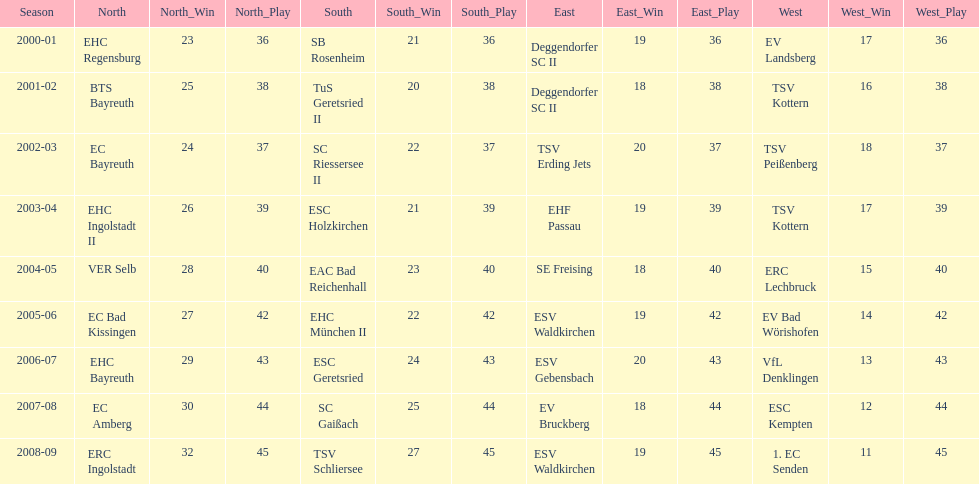Who secured the win in the south subsequent to esc geretsried's participation in the 2006-07 season? SC Gaißach. Would you mind parsing the complete table? {'header': ['Season', 'North', 'North_Win', 'North_Play', 'South', 'South_Win', 'South_Play', 'East', 'East_Win', 'East_Play', 'West', 'West_Win', 'West_Play'], 'rows': [['2000-01', 'EHC Regensburg', '23', '36', 'SB Rosenheim', '21', '36', 'Deggendorfer SC II', '19', '36', 'EV Landsberg', '17', '36'], ['2001-02', 'BTS Bayreuth', '25', '38', 'TuS Geretsried II', '20', '38', 'Deggendorfer SC II', '18', '38', 'TSV Kottern', '16', '38'], ['2002-03', 'EC Bayreuth', '24', '37', 'SC Riessersee II', '22', '37', 'TSV Erding Jets', '20', '37', 'TSV Peißenberg', '18', '37'], ['2003-04', 'EHC Ingolstadt II', '26', '39', 'ESC Holzkirchen', '21', '39', 'EHF Passau', '19', '39', 'TSV Kottern', '17', '39'], ['2004-05', 'VER Selb', '28', '40', 'EAC Bad Reichenhall', '23', '40', 'SE Freising', '18', '40', 'ERC Lechbruck', '15', '40'], ['2005-06', 'EC Bad Kissingen', '27', '42', 'EHC München II', '22', '42', 'ESV Waldkirchen', '19', '42', 'EV Bad Wörishofen', '14', '42'], ['2006-07', 'EHC Bayreuth', '29', '43', 'ESC Geretsried', '24', '43', 'ESV Gebensbach', '20', '43', 'VfL Denklingen', '13', '43'], ['2007-08', 'EC Amberg', '30', '44', 'SC Gaißach', '25', '44', 'EV Bruckberg', '18', '44', 'ESC Kempten', '12', '44'], ['2008-09', 'ERC Ingolstadt', '32', '45', 'TSV Schliersee', '27', '45', 'ESV Waldkirchen', '19', '45', '1. EC Senden', '11', '45']]} 